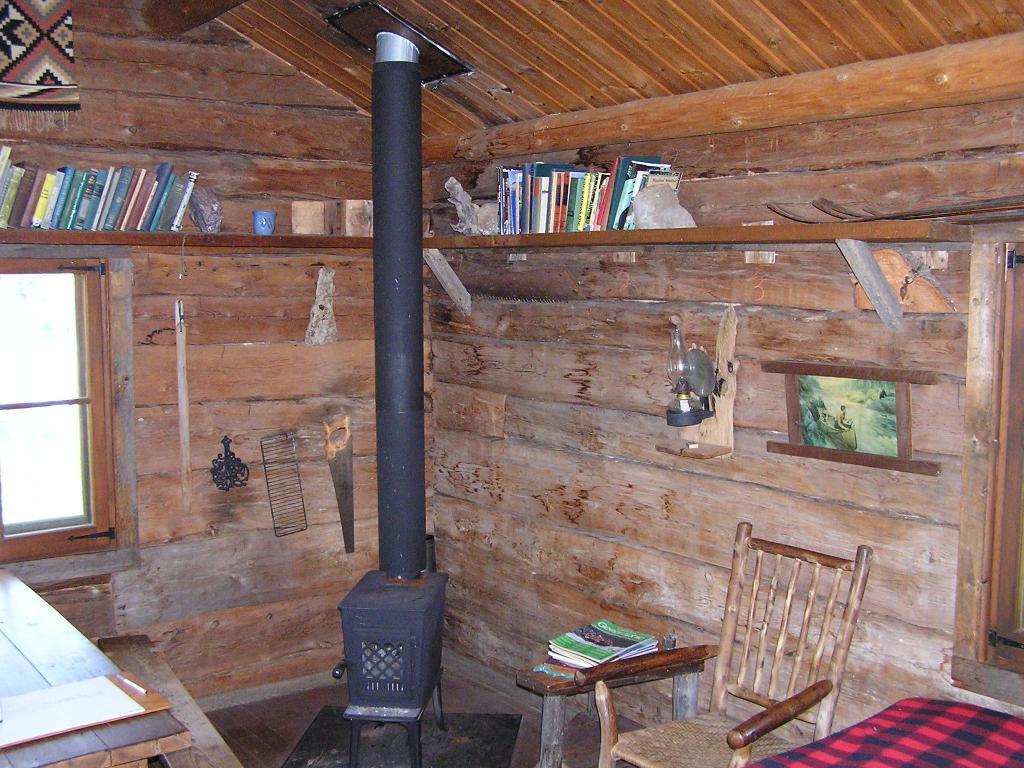Describe this image in one or two sentences. In this image I see a rack on which there are lot of books and I see a chair, a table , few things and a photo frame over here. In the background I see the window. 